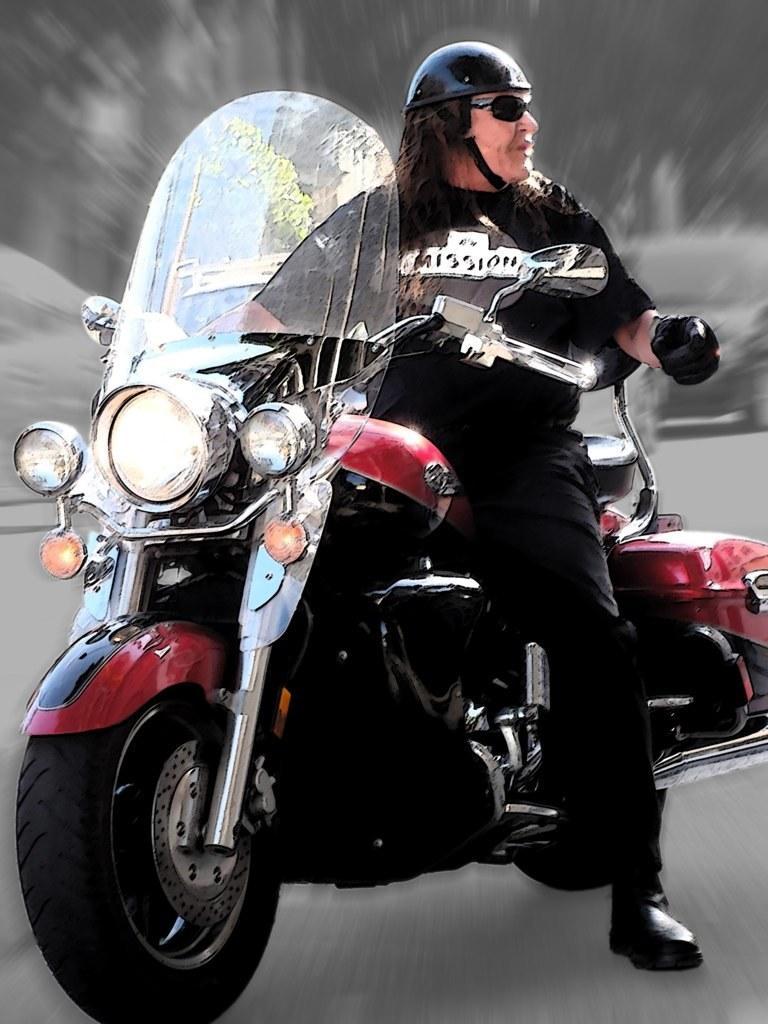Could you give a brief overview of what you see in this image? In this picture we can see man wore helmet, goggle sitting on bike and in background it is blur. 